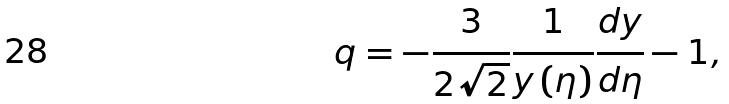<formula> <loc_0><loc_0><loc_500><loc_500>q = - \frac { 3 } { 2 \sqrt { 2 } } \frac { 1 } { y \left ( \eta \right ) } \frac { d y } { d \eta } - 1 ,</formula> 